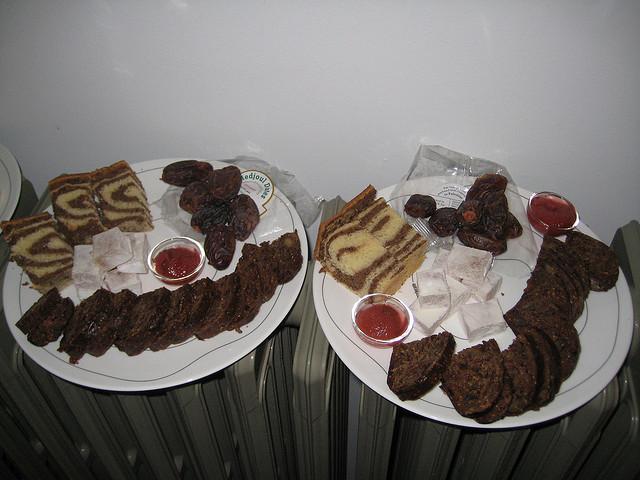What are the trays sitting on?
Keep it brief. Radiator. Would these taste sweet?
Keep it brief. Yes. Are the treats on both trays the same kinds?
Answer briefly. Yes. What type of bread is shown?
Keep it brief. Rye. What have been chopped?
Keep it brief. Bread. 